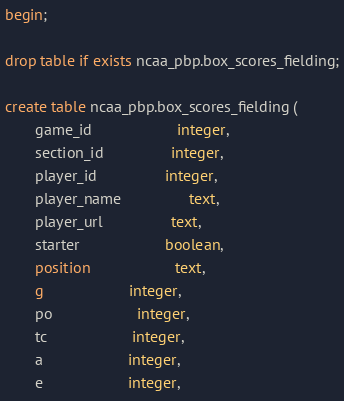Convert code to text. <code><loc_0><loc_0><loc_500><loc_500><_SQL_>begin;

drop table if exists ncaa_pbp.box_scores_fielding;

create table ncaa_pbp.box_scores_fielding (
       game_id					integer,
       section_id				integer,
       player_id				integer,
       player_name				text,
       player_url				text,
       starter					boolean,
       position					text,
       g					integer,
       po					integer,
       tc					integer,
       a					integer,
       e					integer,</code> 